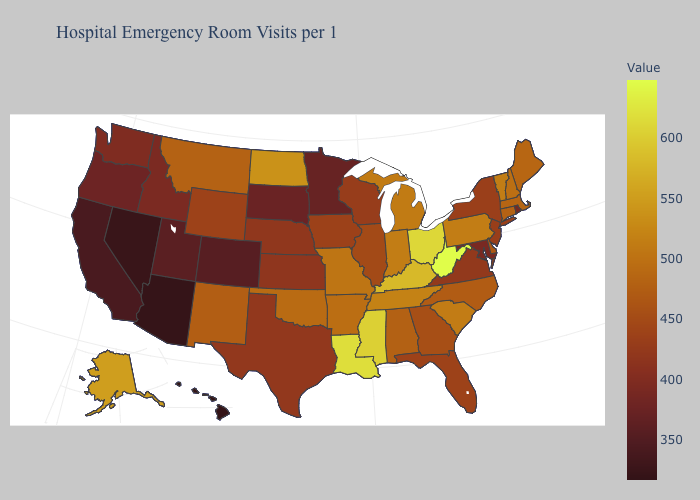Does Maine have the highest value in the USA?
Answer briefly. No. Does Illinois have the highest value in the MidWest?
Quick response, please. No. Among the states that border Texas , does Louisiana have the highest value?
Quick response, please. Yes. Among the states that border New Mexico , which have the lowest value?
Keep it brief. Arizona. Among the states that border Arkansas , does Louisiana have the highest value?
Concise answer only. Yes. Which states have the lowest value in the USA?
Keep it brief. Hawaii. Which states hav the highest value in the West?
Short answer required. Alaska. 